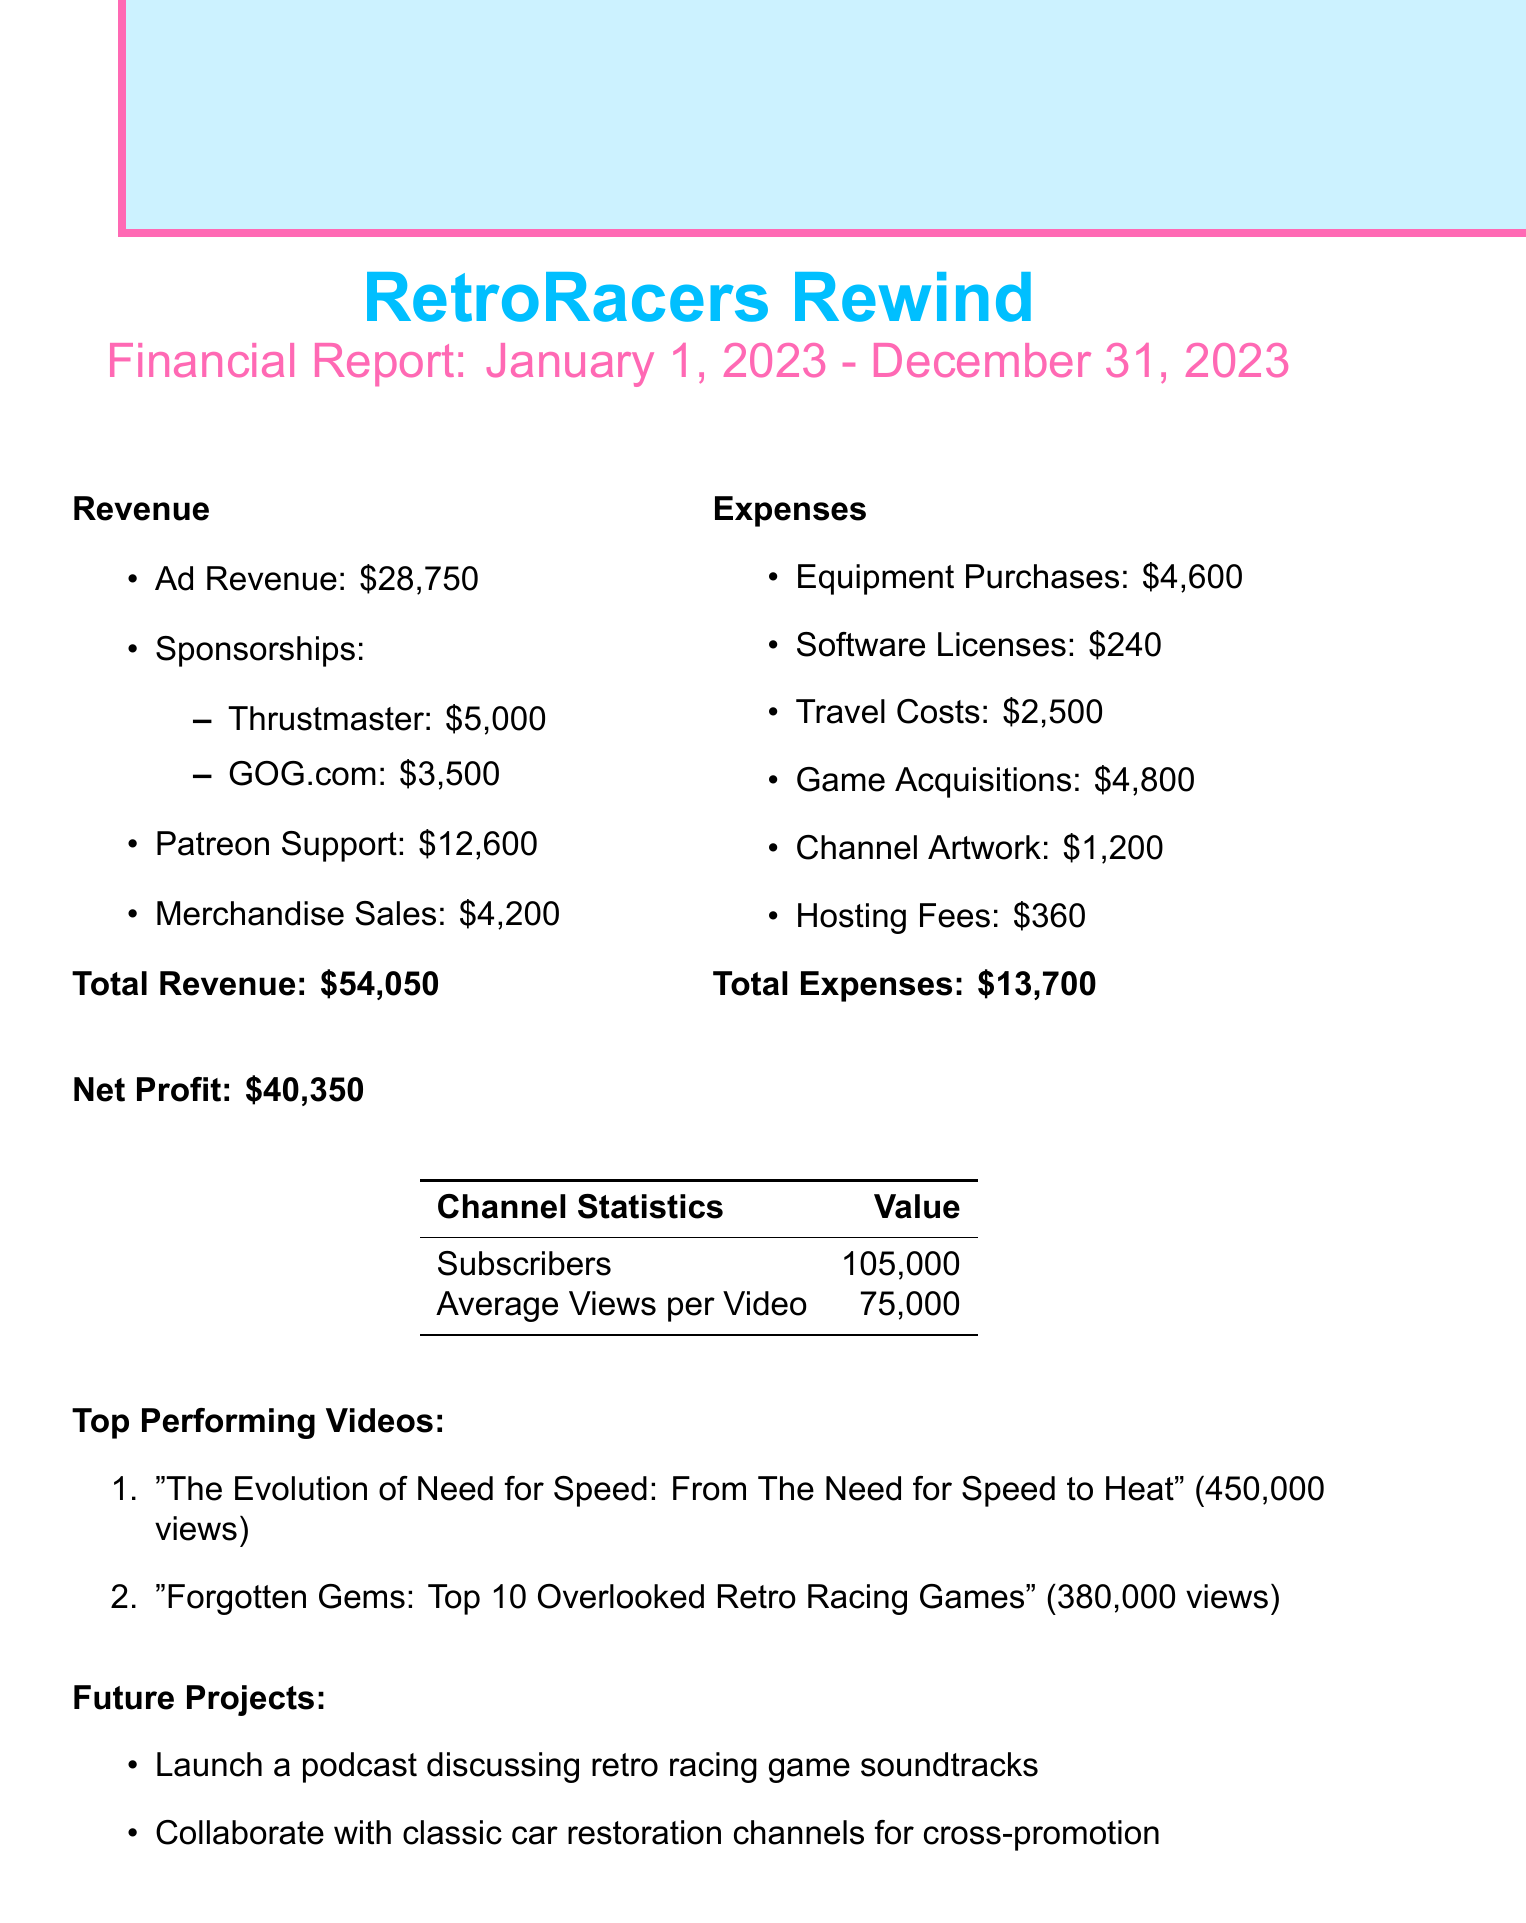what is the total revenue? The total revenue is the sum of all revenue sources in the document: ad revenue, sponsorships, Patreon support, and merchandise sales.
Answer: $54,050 how much did Thrustmaster sponsor the channel? Thrustmaster is listed as a sponsor in the revenue section of the document with a specific amount.
Answer: $5,000 what are the total expenses? The total expenses are calculated by summing all the listed expenses in the document.
Answer: $13,700 what is the net profit? Net profit is defined as total revenue minus total expenses, as shown in the financial report.
Answer: $40,350 how many subscribers does the channel have? The document specifies the number of subscribers the channel has as part of its statistics section.
Answer: 105,000 which video has the highest views? The document lists the top-performing videos and their views, with the highest view count presented first.
Answer: "The Evolution of Need for Speed: From The Need for Speed to Heat" what was the travel cost for the year? The travel costs are detailed in the expenses section, specifically for retro gaming conventions.
Answer: $2,500 what software license cost is mentioned in the report? The report includes specific software licenses and their associated costs, detailing the specific license mentioned.
Answer: $240 what future project involves retro racing game soundtracks? One of the future project ideas mentioned in the document includes a specific focus on retro racing game soundtracks.
Answer: Launch a podcast discussing retro racing game soundtracks 